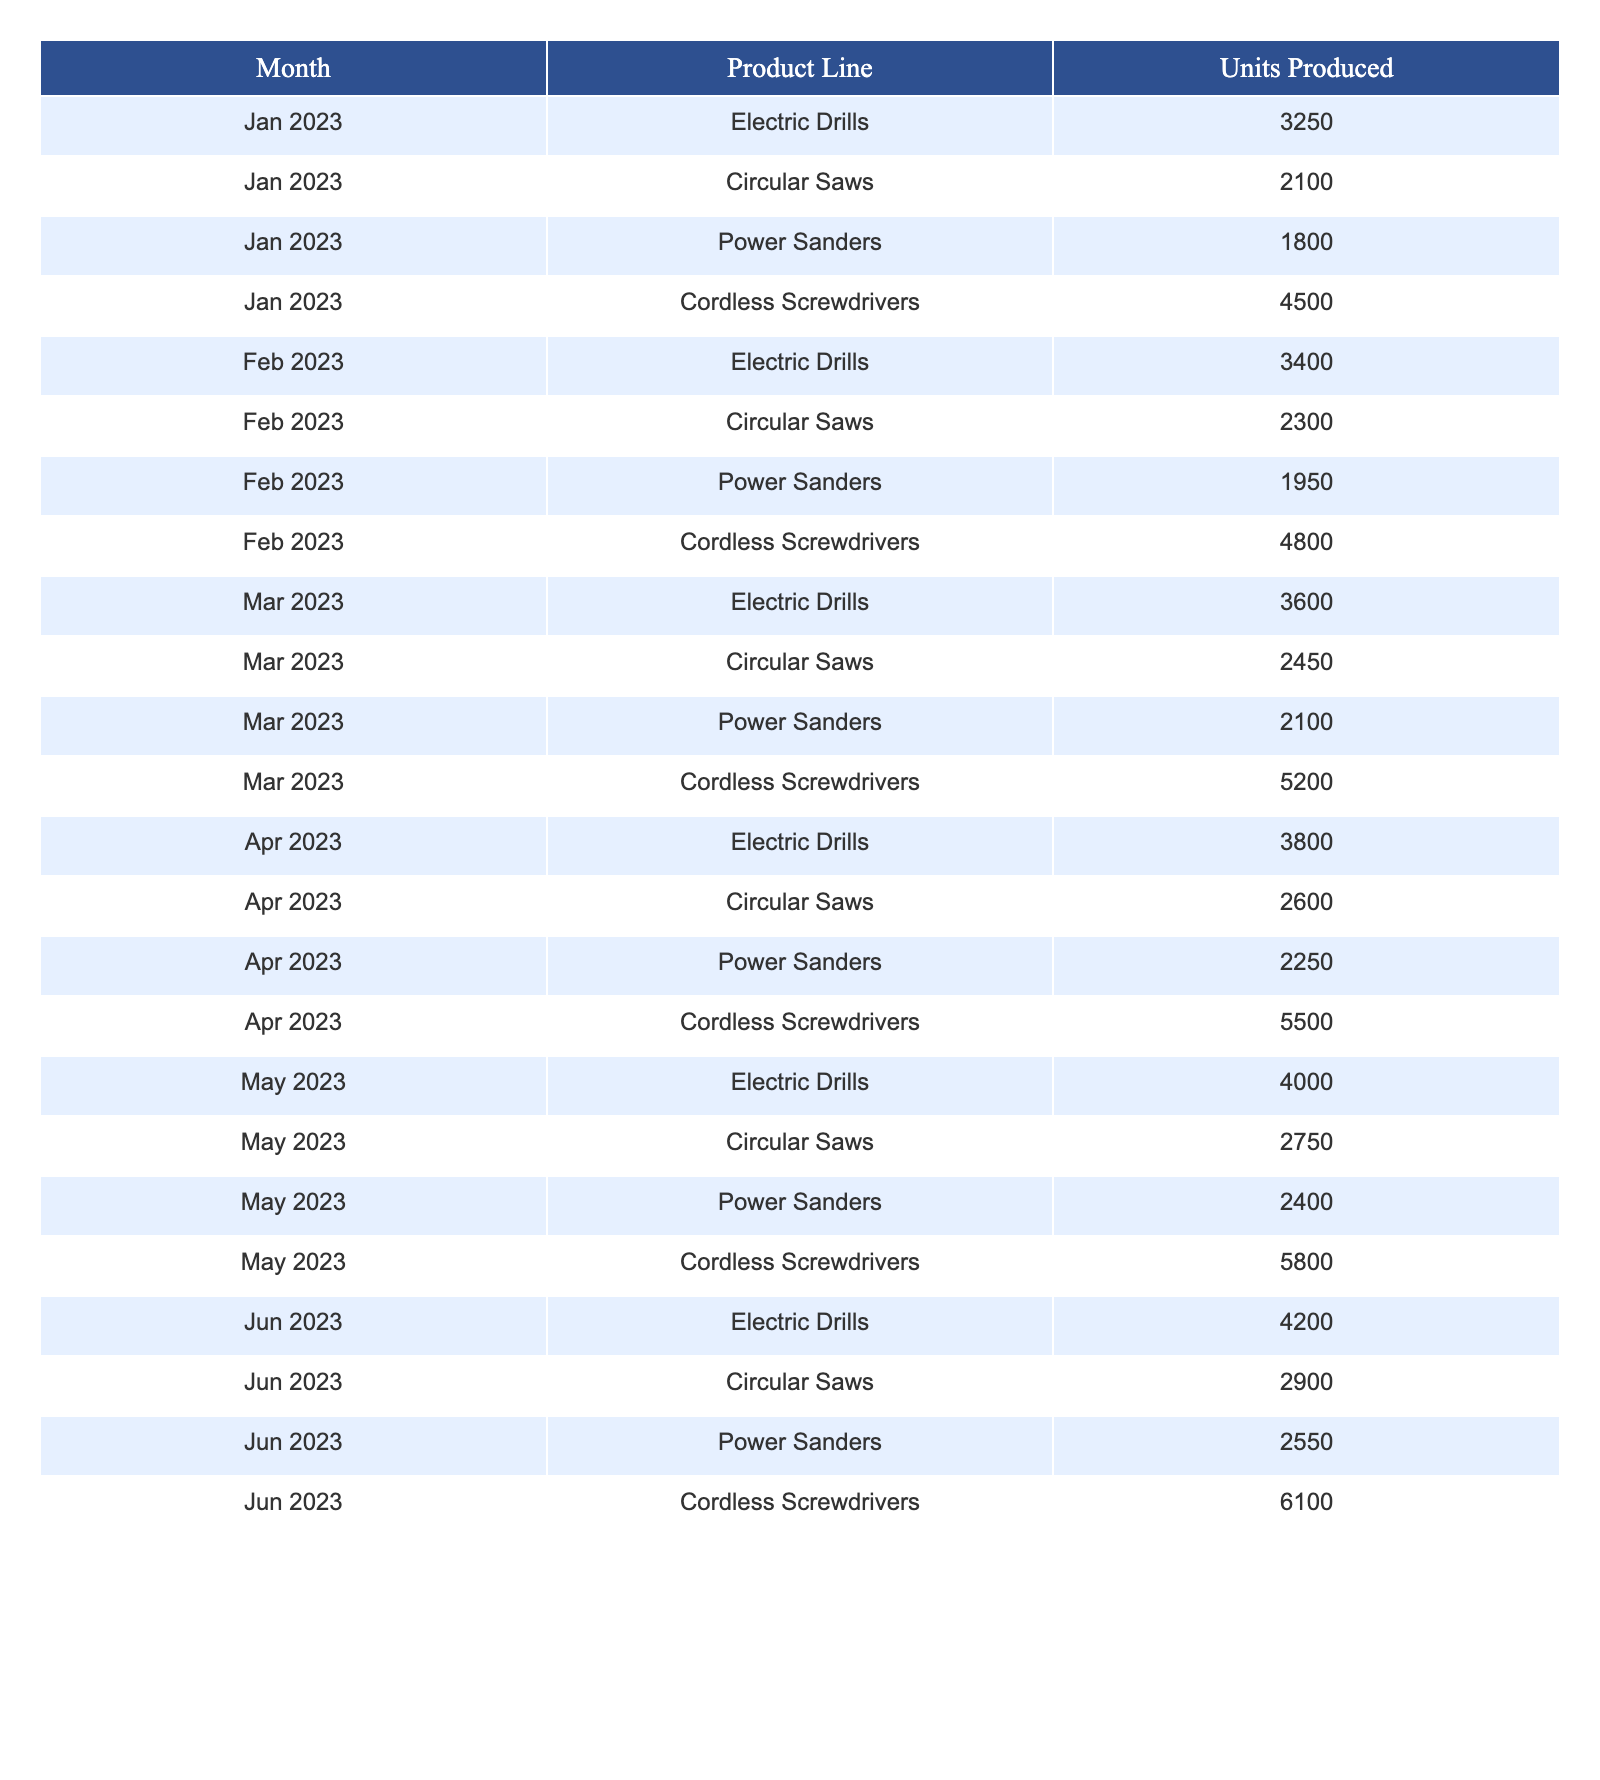What was the highest production output in June 2023? In June 2023, the product line with the highest production output is Cordless Screwdrivers, which produced 6100 units.
Answer: 6100 Which product line had the least production in January 2023? In January 2023, the product line with the least production output is Power Sanders, which produced 1800 units.
Answer: Power Sanders What is the average production output for Electric Drills from January to June 2023? The production outputs for Electric Drills from January to June 2023 are 3250, 3400, 3600, 3800, 4000, and 4200. Summing these values gives 3250 + 3400 + 3600 + 3800 + 4000 + 4200 = 22050. Divide by 6 to find the average: 22050 / 6 = 3675.
Answer: 3675 Was there an increase in production for Circular Saws from January to February 2023? In January 2023, Circular Saws produced 2100 units, while in February 2023, they produced 2300 units. Since 2300 is greater than 2100, this indicates an increase.
Answer: Yes What was the total production output for Cordless Screwdrivers from January to June 2023? The production outputs for Cordless Screwdrivers from January to June 2023 are 4500, 4800, 5200, 5500, 5800, and 6100. Summing these values gives: 4500 + 4800 + 5200 + 5500 + 5800 + 6100 = 31900.
Answer: 31900 How many units of Power Sanders were produced in March and April 2023 combined? The production outputs for Power Sanders in March and April 2023 are 2100 and 2250 respectively. Adding these gives: 2100 + 2250 = 4350 units.
Answer: 4350 Which month experienced the most significant growth in production output for Electric Drills? Analyzing the monthly production outputs for Electric Drills: Jan: 3250, Feb: 3400, Mar: 3600, Apr: 3800, May: 4000, Jun: 4200. The growth from May to Jun is 4200 - 4000 = 200 units, which is the lowest increase compared to other months. The highest growth is from Apr to May, which is 4000 - 3800 = 200 units, indicating consistent growth.
Answer: No significant growth; consistent increases throughout What percentage increase was there in production for Circular Saws from January to June 2023? The production output for Circular Saws in January 2023 was 2100 units, and in June 2023 it was 2900 units. The increase is 2900 - 2100 = 800 units. To find the percentage increase: (800 / 2100) * 100 = approximately 38.1%.
Answer: 38.1% Which product line consistently increased production each month from January to June 2023? Observing the production outputs for all product lines, Electric Drills, Circular Saws, Power Sanders, and Cordless Screwdrivers show consistent increases in unit production from January to June 2023.
Answer: All product lines consistently increased 